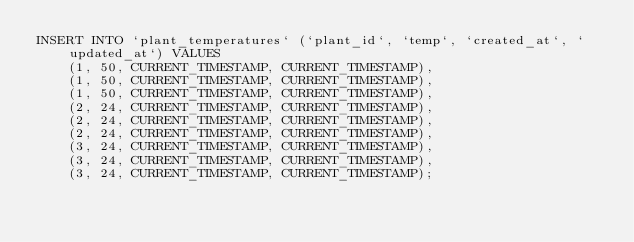<code> <loc_0><loc_0><loc_500><loc_500><_SQL_>INSERT INTO `plant_temperatures` (`plant_id`, `temp`, `created_at`, `updated_at`) VALUES 
    (1, 50, CURRENT_TIMESTAMP, CURRENT_TIMESTAMP),
    (1, 50, CURRENT_TIMESTAMP, CURRENT_TIMESTAMP),
    (1, 50, CURRENT_TIMESTAMP, CURRENT_TIMESTAMP),
    (2, 24, CURRENT_TIMESTAMP, CURRENT_TIMESTAMP),
    (2, 24, CURRENT_TIMESTAMP, CURRENT_TIMESTAMP),
    (2, 24, CURRENT_TIMESTAMP, CURRENT_TIMESTAMP),
    (3, 24, CURRENT_TIMESTAMP, CURRENT_TIMESTAMP),
    (3, 24, CURRENT_TIMESTAMP, CURRENT_TIMESTAMP),
    (3, 24, CURRENT_TIMESTAMP, CURRENT_TIMESTAMP);</code> 